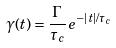<formula> <loc_0><loc_0><loc_500><loc_500>\gamma ( t ) = \frac { \Gamma } { \tau _ { c } } \, e ^ { - | t | / \tau _ { c } }</formula> 